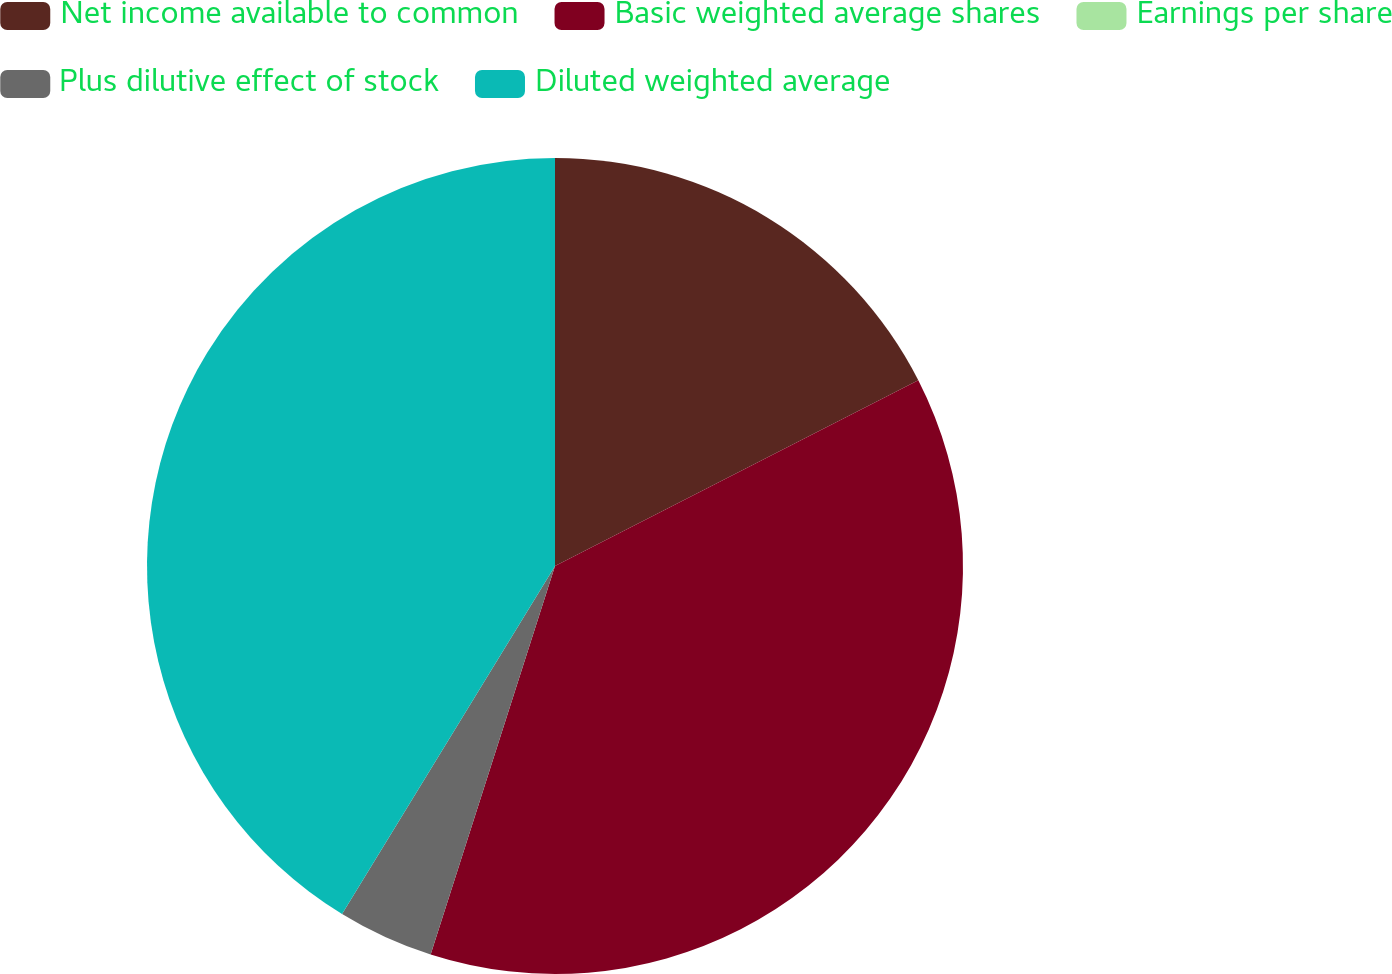Convert chart to OTSL. <chart><loc_0><loc_0><loc_500><loc_500><pie_chart><fcel>Net income available to common<fcel>Basic weighted average shares<fcel>Earnings per share<fcel>Plus dilutive effect of stock<fcel>Diluted weighted average<nl><fcel>17.48%<fcel>37.45%<fcel>0.0%<fcel>3.81%<fcel>41.26%<nl></chart> 